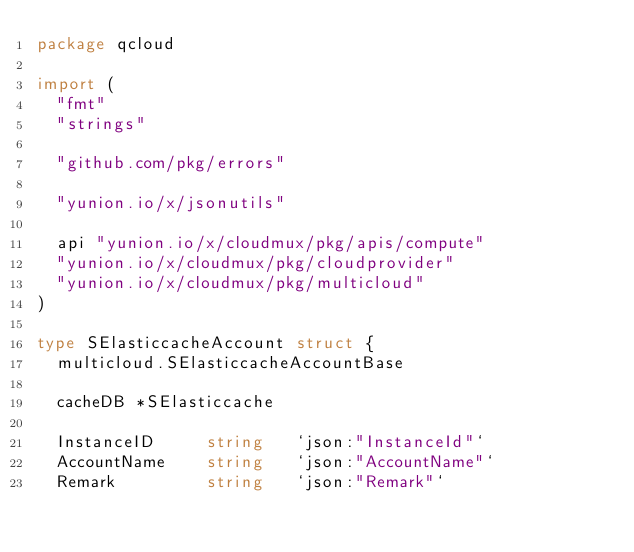<code> <loc_0><loc_0><loc_500><loc_500><_Go_>package qcloud

import (
	"fmt"
	"strings"

	"github.com/pkg/errors"

	"yunion.io/x/jsonutils"

	api "yunion.io/x/cloudmux/pkg/apis/compute"
	"yunion.io/x/cloudmux/pkg/cloudprovider"
	"yunion.io/x/cloudmux/pkg/multicloud"
)

type SElasticcacheAccount struct {
	multicloud.SElasticcacheAccountBase

	cacheDB *SElasticcache

	InstanceID     string   `json:"InstanceId"`
	AccountName    string   `json:"AccountName"`
	Remark         string   `json:"Remark"`</code> 